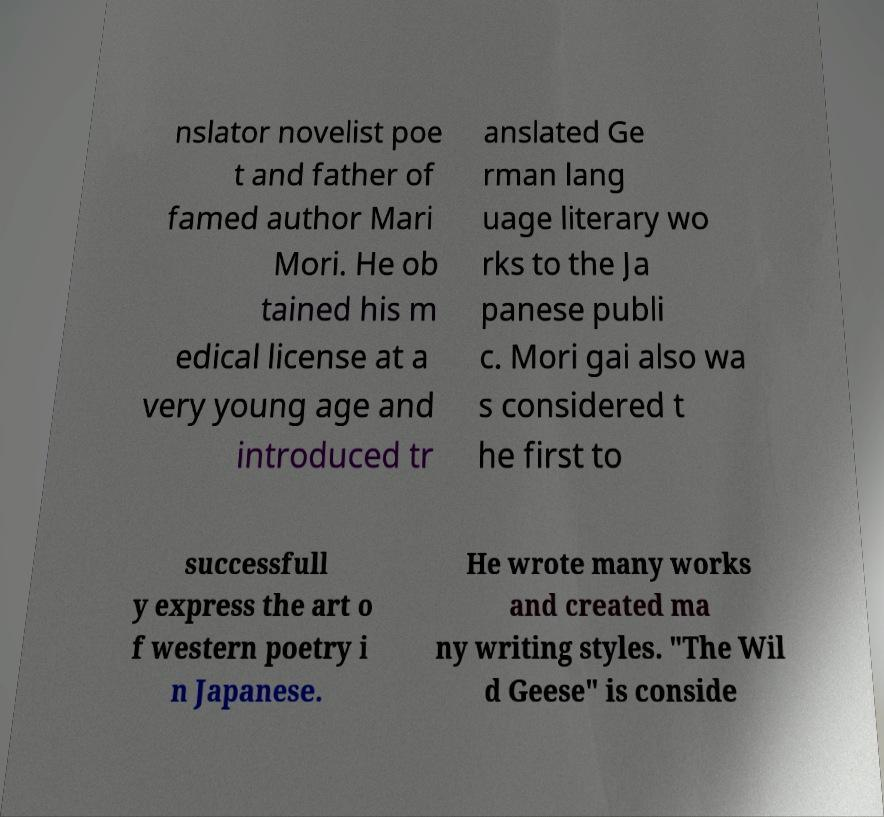For documentation purposes, I need the text within this image transcribed. Could you provide that? nslator novelist poe t and father of famed author Mari Mori. He ob tained his m edical license at a very young age and introduced tr anslated Ge rman lang uage literary wo rks to the Ja panese publi c. Mori gai also wa s considered t he first to successfull y express the art o f western poetry i n Japanese. He wrote many works and created ma ny writing styles. "The Wil d Geese" is conside 